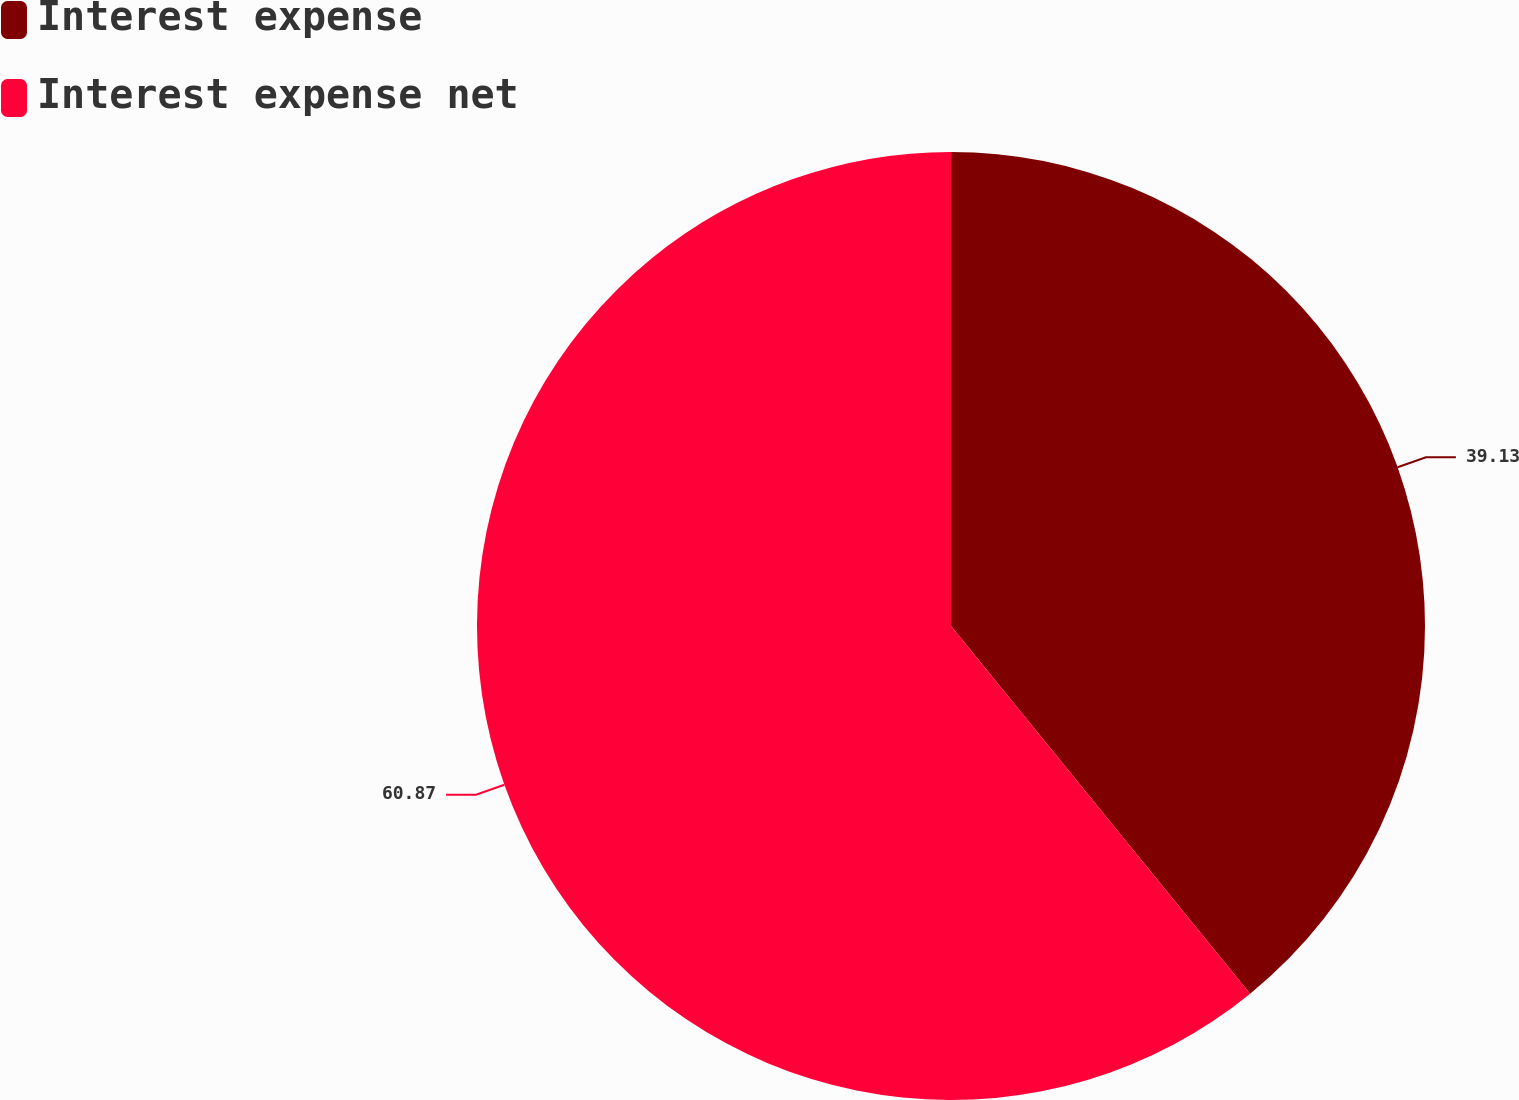<chart> <loc_0><loc_0><loc_500><loc_500><pie_chart><fcel>Interest expense<fcel>Interest expense net<nl><fcel>39.13%<fcel>60.87%<nl></chart> 